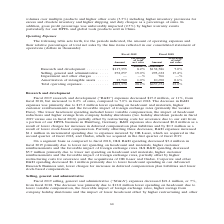According to Coherent's financial document, What was total operating expenses in 2019? According to the financial document, $403,370 (in thousands). The relevant text states: "Total operating expenses . $403,370 28.2% $437,674 23.0%..." Also, What was  Amortization of intangible assets  in 2018? According to the financial document, 10,690 (in thousands). The relevant text states: "% Amortization of intangible assets . 13,760 1.0% 10,690 0.6%..." Also, In which years was operating expenses calculated? The document shows two values: 2019 and 2018. From the document: "Fiscal 2019 Fiscal 2018 Percentage Percentage of total of total Amount net sales Amount net sales (Dollars in t Fiscal 2019 Fiscal 2018 Percentage Per..." Additionally, In which year was Amortization of intangible assets a higher percentage of total net sales? According to the financial document, 2019. The relevant text states: "Fiscal 2019 Fiscal 2018 Percentage Percentage of total of total Amount net sales Amount net sales (Dollars in t..." Also, can you calculate: What was the change in the amount of Amortization of intangible assets in 2019 from 2018? Based on the calculation: 13,760-10,690, the result is 3070 (in thousands). This is based on the information: "% Amortization of intangible assets . 13,760 1.0% 10,690 0.6% . — —% 766 —% Amortization of intangible assets . 13,760 1.0% 10,690 0.6%..." The key data points involved are: 10,690, 13,760. Also, can you calculate: What was the percentage change in the amount of Amortization of intangible assets in 2019 from 2018? To answer this question, I need to perform calculations using the financial data. The calculation is: (13,760-10,690)/10,690, which equals 28.72 (percentage). This is based on the information: "% Amortization of intangible assets . 13,760 1.0% 10,690 0.6% . — —% 766 —% Amortization of intangible assets . 13,760 1.0% 10,690 0.6%..." The key data points involved are: 10,690, 13,760. 